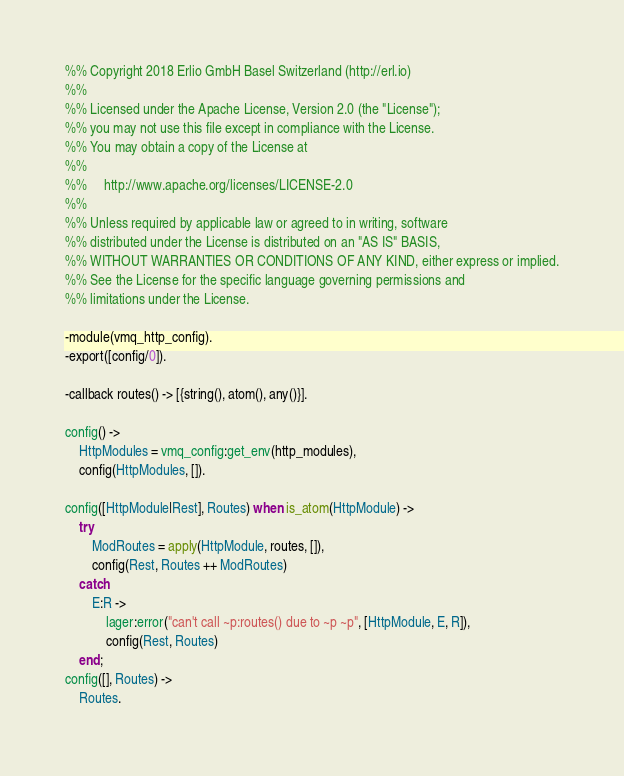Convert code to text. <code><loc_0><loc_0><loc_500><loc_500><_Erlang_>%% Copyright 2018 Erlio GmbH Basel Switzerland (http://erl.io)
%%
%% Licensed under the Apache License, Version 2.0 (the "License");
%% you may not use this file except in compliance with the License.
%% You may obtain a copy of the License at
%%
%%     http://www.apache.org/licenses/LICENSE-2.0
%%
%% Unless required by applicable law or agreed to in writing, software
%% distributed under the License is distributed on an "AS IS" BASIS,
%% WITHOUT WARRANTIES OR CONDITIONS OF ANY KIND, either express or implied.
%% See the License for the specific language governing permissions and
%% limitations under the License.

-module(vmq_http_config).
-export([config/0]).

-callback routes() -> [{string(), atom(), any()}].

config() ->
    HttpModules = vmq_config:get_env(http_modules),
    config(HttpModules, []).

config([HttpModule|Rest], Routes) when is_atom(HttpModule) ->
    try
        ModRoutes = apply(HttpModule, routes, []),
        config(Rest, Routes ++ ModRoutes)
    catch
        E:R ->
            lager:error("can't call ~p:routes() due to ~p ~p", [HttpModule, E, R]),
            config(Rest, Routes)
    end;
config([], Routes) ->
    Routes.
</code> 